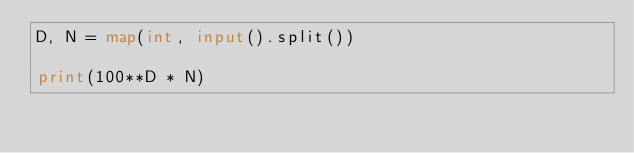Convert code to text. <code><loc_0><loc_0><loc_500><loc_500><_Python_>D, N = map(int, input().split())

print(100**D * N)</code> 